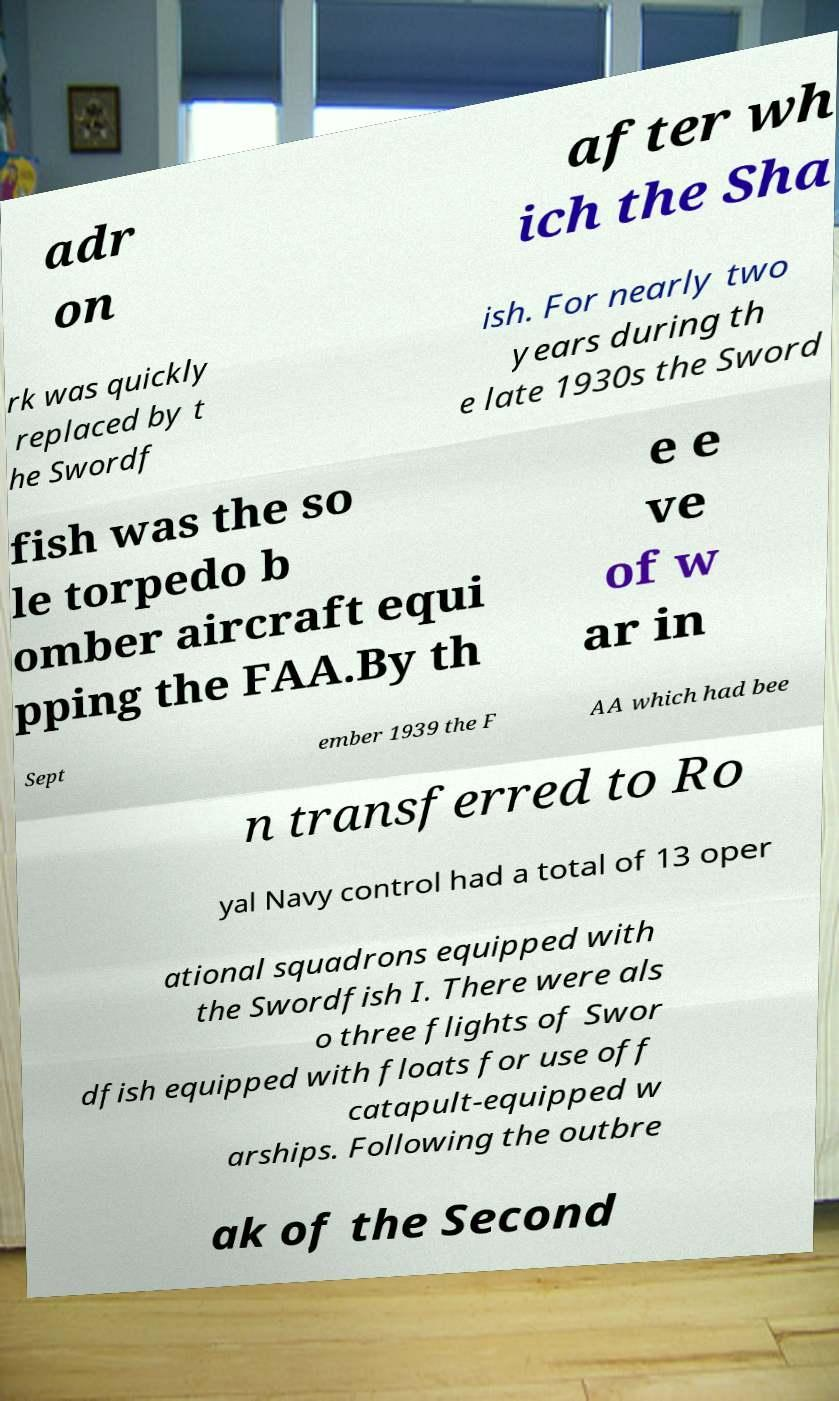Please read and relay the text visible in this image. What does it say? adr on after wh ich the Sha rk was quickly replaced by t he Swordf ish. For nearly two years during th e late 1930s the Sword fish was the so le torpedo b omber aircraft equi pping the FAA.By th e e ve of w ar in Sept ember 1939 the F AA which had bee n transferred to Ro yal Navy control had a total of 13 oper ational squadrons equipped with the Swordfish I. There were als o three flights of Swor dfish equipped with floats for use off catapult-equipped w arships. Following the outbre ak of the Second 